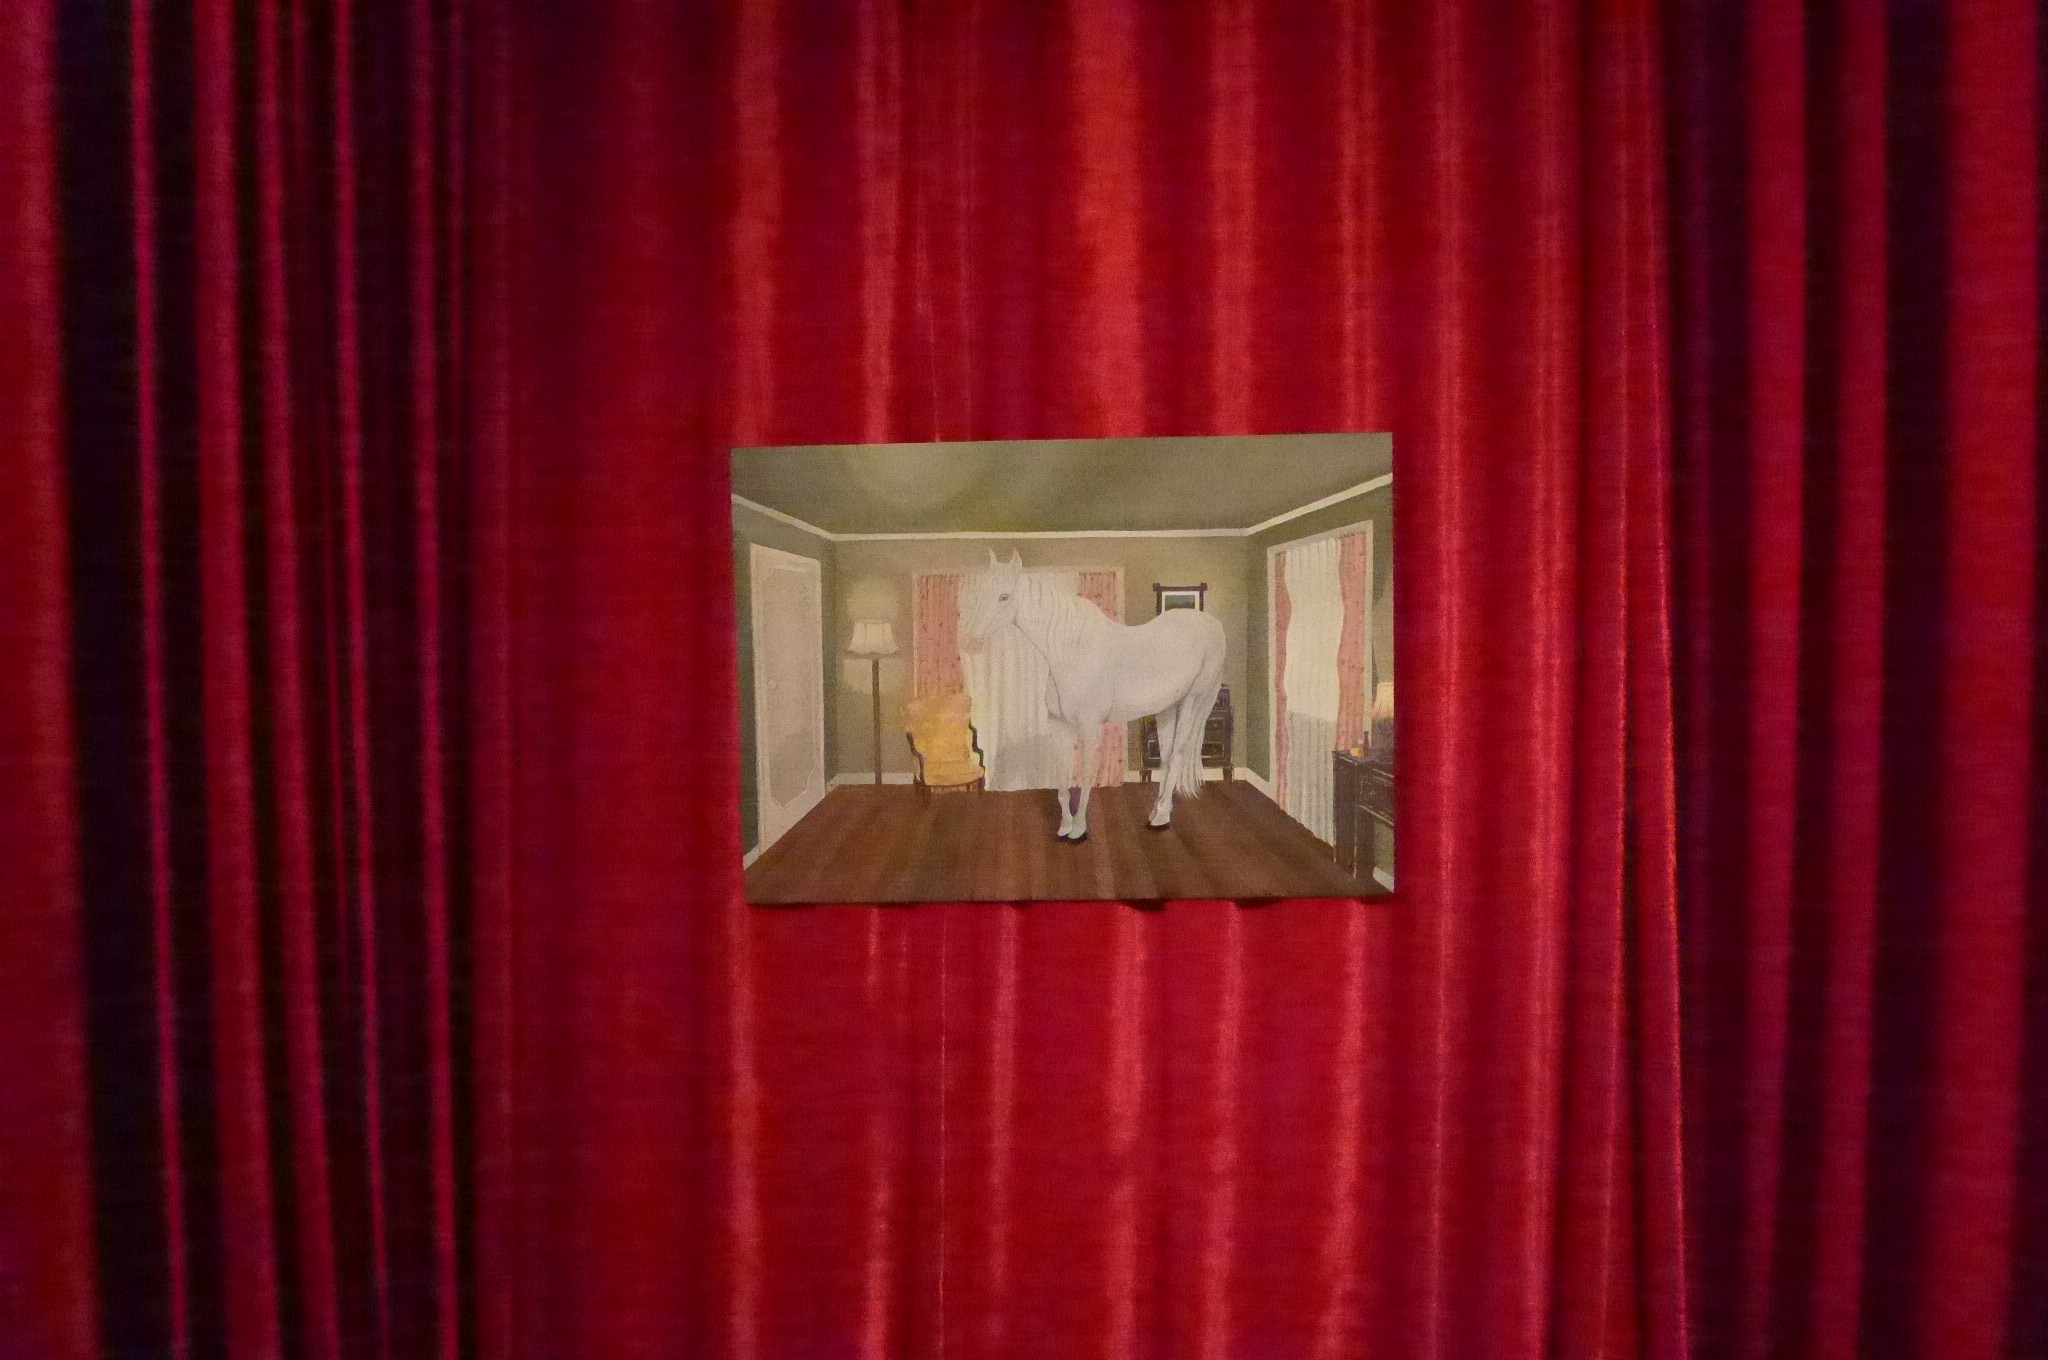Can you describe this image briefly? In this image we can see a photograph and a curtain. We can see a horse, chair, lamp, floor, walls, frame and roof on the photograph. 